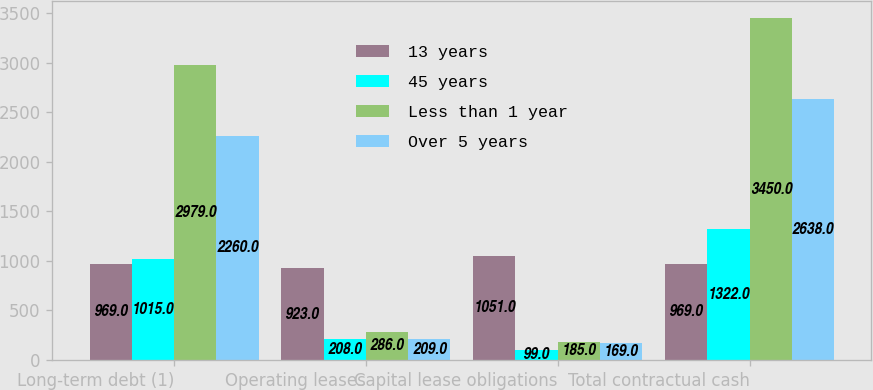Convert chart to OTSL. <chart><loc_0><loc_0><loc_500><loc_500><stacked_bar_chart><ecel><fcel>Long-term debt (1)<fcel>Operating leases<fcel>Capital lease obligations<fcel>Total contractual cash<nl><fcel>13 years<fcel>969<fcel>923<fcel>1051<fcel>969<nl><fcel>45 years<fcel>1015<fcel>208<fcel>99<fcel>1322<nl><fcel>Less than 1 year<fcel>2979<fcel>286<fcel>185<fcel>3450<nl><fcel>Over 5 years<fcel>2260<fcel>209<fcel>169<fcel>2638<nl></chart> 